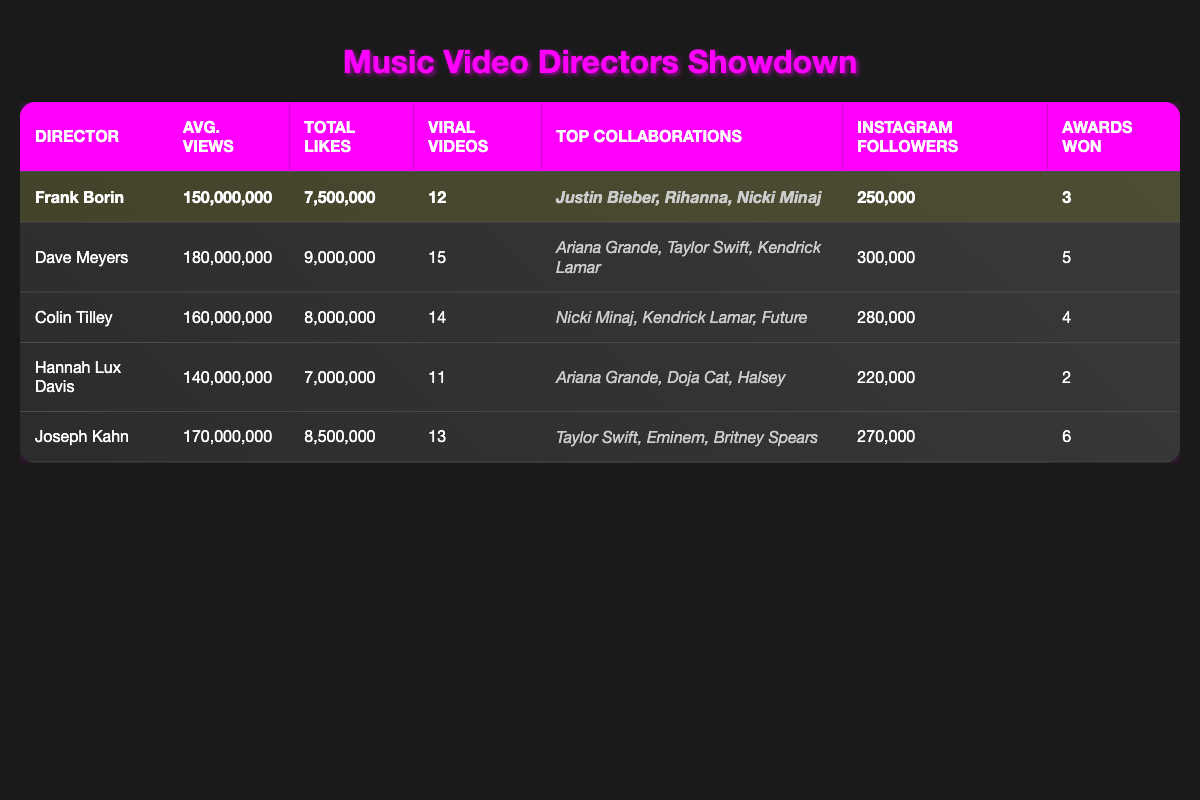What is the average number of views for Frank Borin's music videos? Frank Borin's average views is directly listed in the table as 150,000,000.
Answer: 150,000,000 Which director has the highest total likes? By comparing the 'Total Likes' column, Dave Meyers has 9,000,000 likes which is higher than any other director.
Answer: Dave Meyers How many more viral videos does Joseph Kahn have compared to Frank Borin? Joseph Kahn has 13 viral videos and Frank Borin has 12. The difference is calculated as 13 - 12 = 1.
Answer: 1 Is it true that Hannah Lux Davis has more Instagram followers than Frank Borin? Checking the 'Instagram Followers' column, Hannah Lux Davis has 220,000 followers and Frank Borin has 250,000. Therefore, it is false.
Answer: False What is the total number of awards won by all directors combined? The awards for each director are summed: 3 (Frank Borin) + 5 (Dave Meyers) + 4 (Colin Tilley) + 2 (Hannah Lux Davis) + 6 (Joseph Kahn) = 20.
Answer: 20 Which director has the best average views out of the directors listed? By comparing the average views, Dave Meyers has 180,000,000 which is the highest among all listed directors.
Answer: Dave Meyers How many directors have won more than three awards? By checking the 'Awards Won' column, two directors, Dave Meyers (5 awards) and Joseph Kahn (6 awards), have won more than three.
Answer: 2 What is the average number of viral videos across all five directors? The total number of viral videos (12 + 15 + 14 + 11 + 13 = 65) divided by the number of directors (5) gives the average: 65 / 5 = 13.
Answer: 13 Does Colin Tilley have more collaborations with top artists than Frank Borin? Frank Borin has 3 collaborations while Colin Tilley has 3 as well; hence they are equal, therefore the answer is false.
Answer: False 